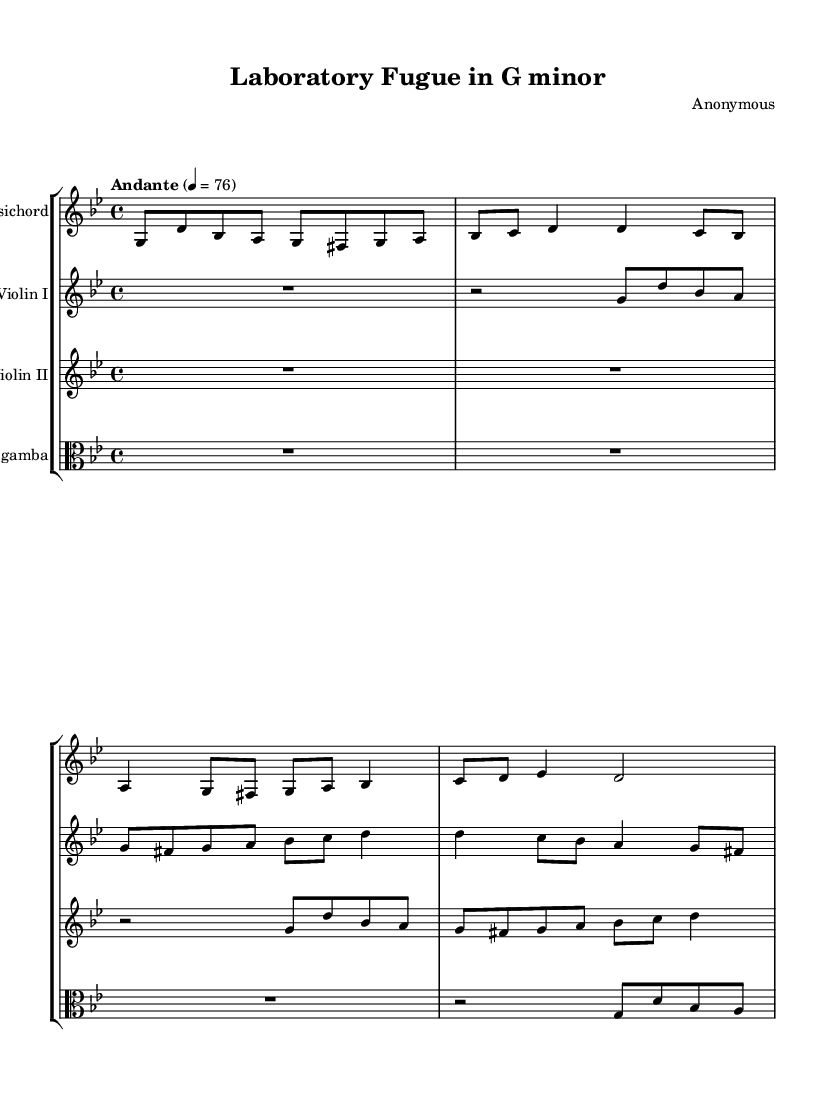What is the key signature of this music? The music is indicated as being in G minor, which is indicated by a single flat in the key signature.
Answer: G minor What is the time signature of this piece? The time signature of the piece is 4/4, meaning there are four beats per measure and the quarter note gets one beat.
Answer: 4/4 What tempo is indicated for this music? The tempo marking states "Andante" with a metronome marking of 76 beats per minute, indicating a moderately slow speed.
Answer: Andante 76 How many instruments are featured in this score? There are four distinct instruments noted in the score, which are the Harpsichord, Violin I, Violin II, and Viola da gamba.
Answer: Four What note starts the Harpsichord melody? The Harpsichord melody starts on the note G, as it is the first note written in the staff.
Answer: G Which instrument has the highest pitch range? The Violin I part is notated in the treble clef and typically has the highest pitch range among the instruments represented.
Answer: Violin I Identify the musical form suggested by the title. The title "Laboratory Fugue in G minor" suggests that the piece is structured as a fugue, which is characterized by interwoven melodies.
Answer: Fugue 